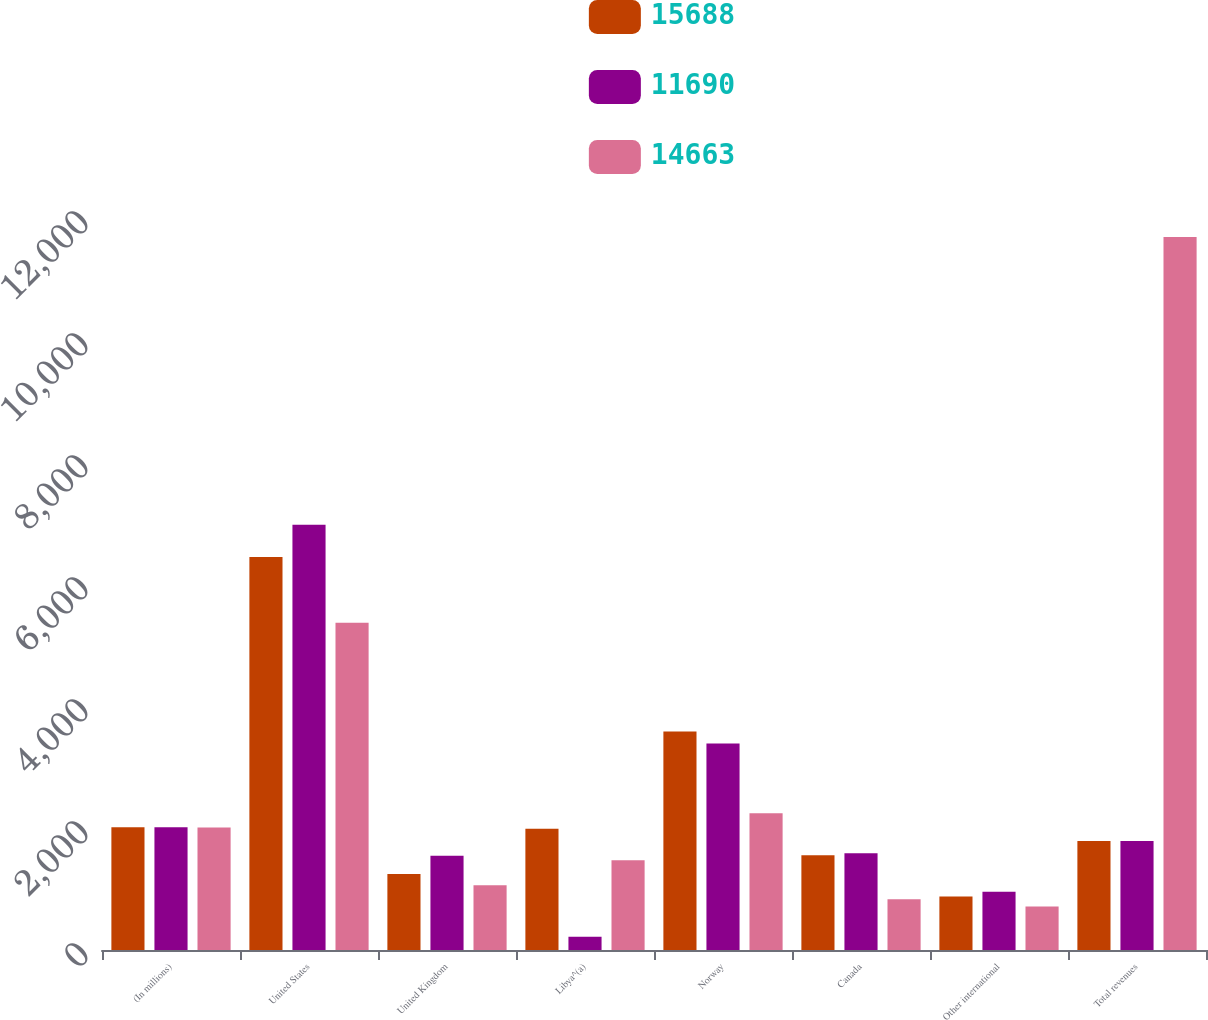Convert chart to OTSL. <chart><loc_0><loc_0><loc_500><loc_500><stacked_bar_chart><ecel><fcel>(In millions)<fcel>United States<fcel>United Kingdom<fcel>Libya^(a)<fcel>Norway<fcel>Canada<fcel>Other international<fcel>Total revenues<nl><fcel>15688<fcel>2012<fcel>6442<fcel>1245<fcel>1989<fcel>3582<fcel>1552<fcel>878<fcel>1788.5<nl><fcel>11690<fcel>2011<fcel>6971<fcel>1546<fcel>216<fcel>3386<fcel>1588<fcel>956<fcel>1788.5<nl><fcel>14663<fcel>2010<fcel>5363<fcel>1063<fcel>1473<fcel>2243<fcel>833<fcel>715<fcel>11690<nl></chart> 